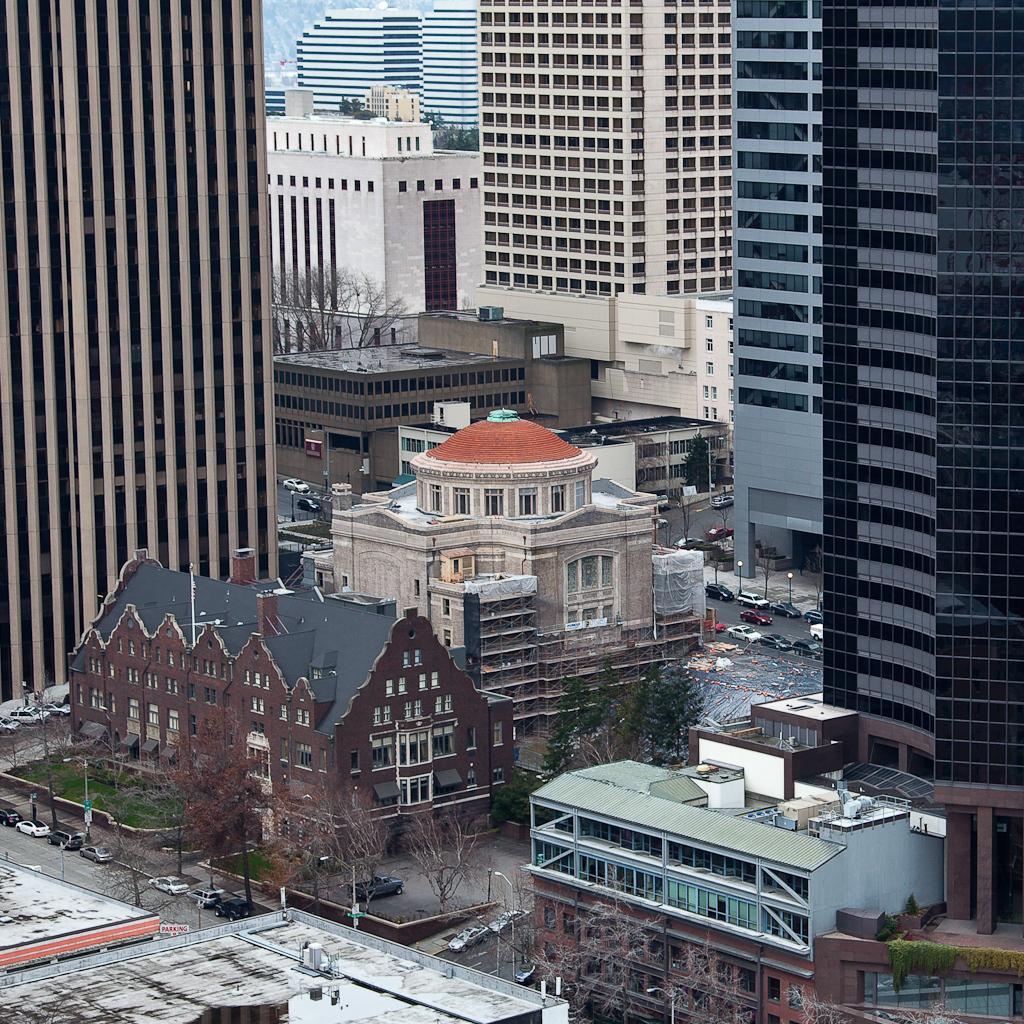Please provide a concise description of this image. In this picture we can see buildings, skyscrapers, trees, poles and some vehicles parked on the road. 